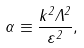<formula> <loc_0><loc_0><loc_500><loc_500>\alpha \equiv \frac { k ^ { 2 } \Lambda ^ { 2 } } { \varepsilon ^ { 2 } } ,</formula> 